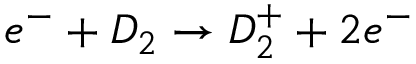<formula> <loc_0><loc_0><loc_500><loc_500>e ^ { - } + D _ { 2 } \rightarrow D _ { 2 } ^ { + } + 2 e ^ { - }</formula> 